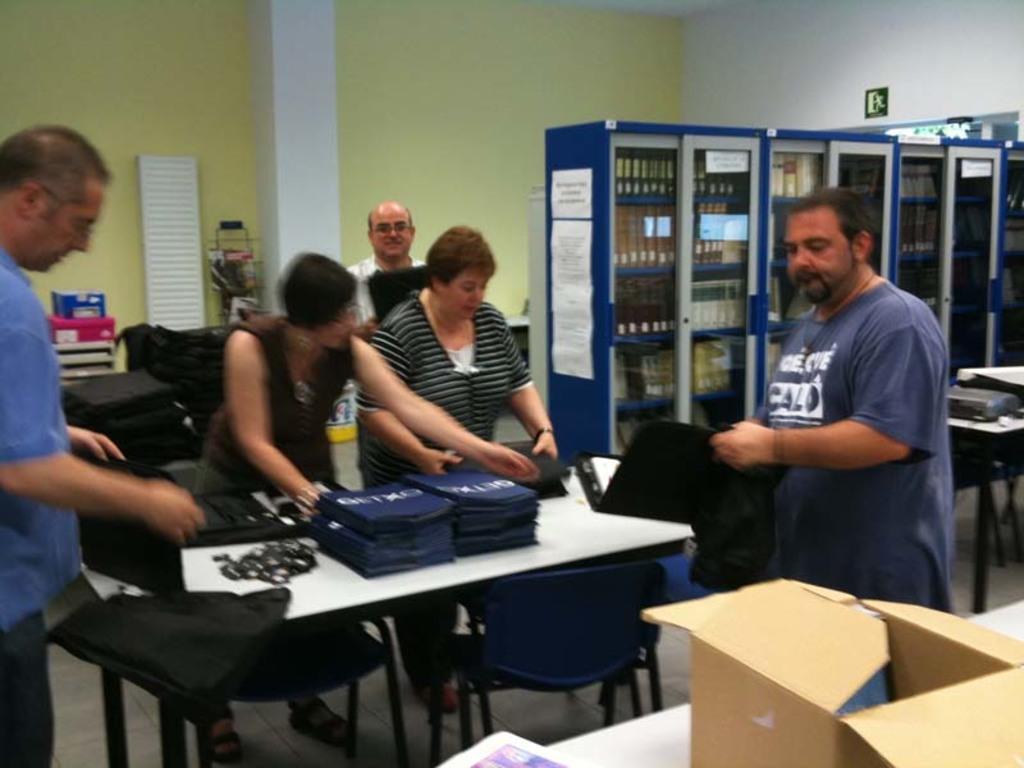Can you describe this image briefly? In this image I can see number of people are standing. I can also see a box, few tables, and few chairs. Here I can see he is holding a file. 